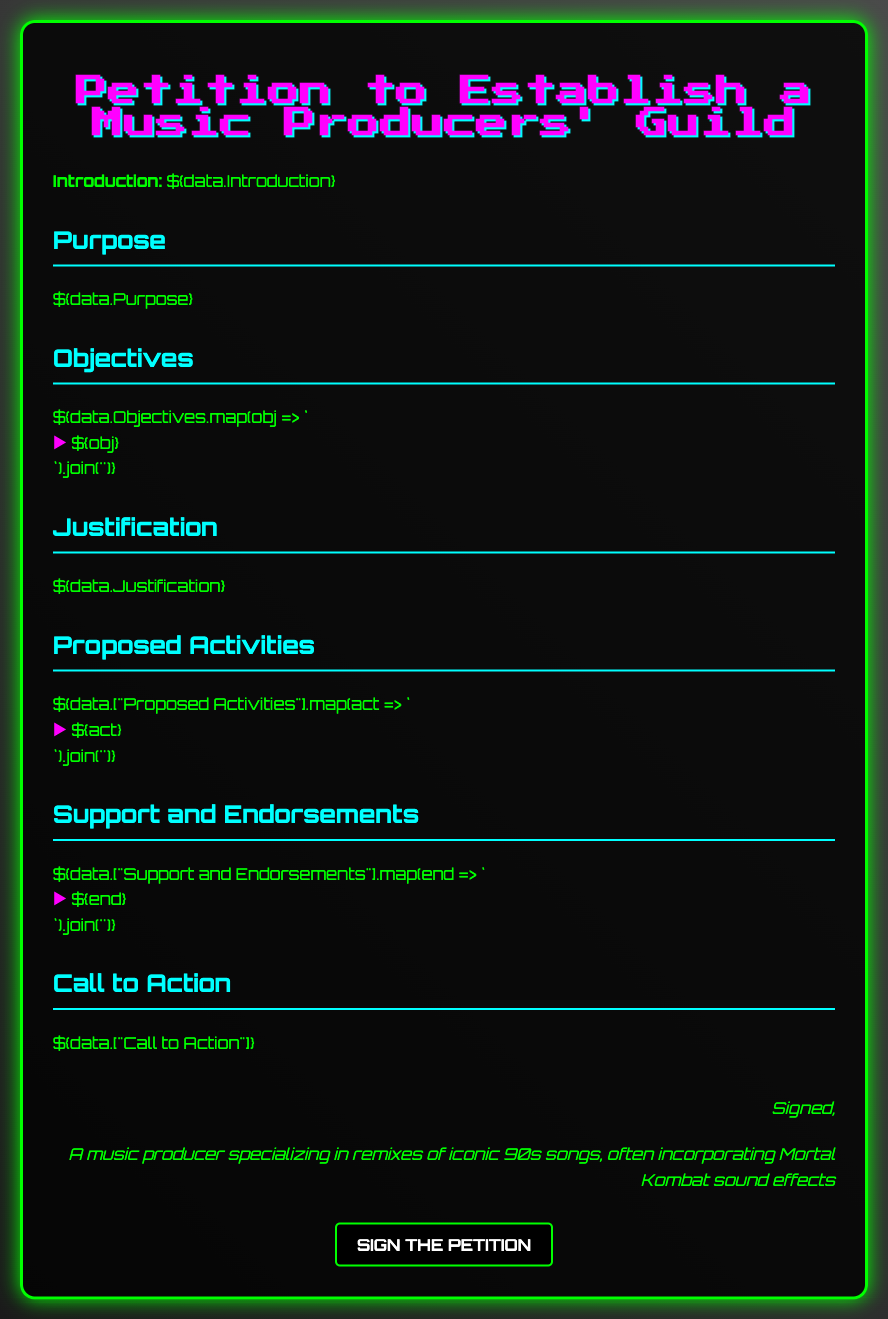What is the purpose of the petition? The petition aims to establish a Music Producers' Guild focused on electronic and remix music.
Answer: Establish a Music Producers' Guild How many objectives are listed in the document? The document lists multiple objectives; counting them gives the answer.
Answer: The number of objectives What activity is proposed for the guild? The proposed activities section will outline potential activities for the guild.
Answer: Activities related to the guild Who signed the petition? The signature section identifies the individual who signed the petition.
Answer: A music producer specializing in remixes of iconic 90s songs, often incorporating Mortal Kombat sound effects What is stated under the justification section? The content in the justification section will provide reasoning for the petition's establishment.
Answer: Justification related content What types of music does the guild focus on? The purpose section mentions the specific types of music the guild will focus on.
Answer: Electronic and remix music What call to action is present in the document? The call to action section encourages individuals to take a specific action regarding the petition.
Answer: Call to Action content What color is used for the text throughout the document? The overall color scheme reveals that a specific color is used prominently for text.
Answer: Green What is the title of the document? The title section of the document clearly states its focus and allows for identification.
Answer: Petition to Establish a Music Producers' Guild 